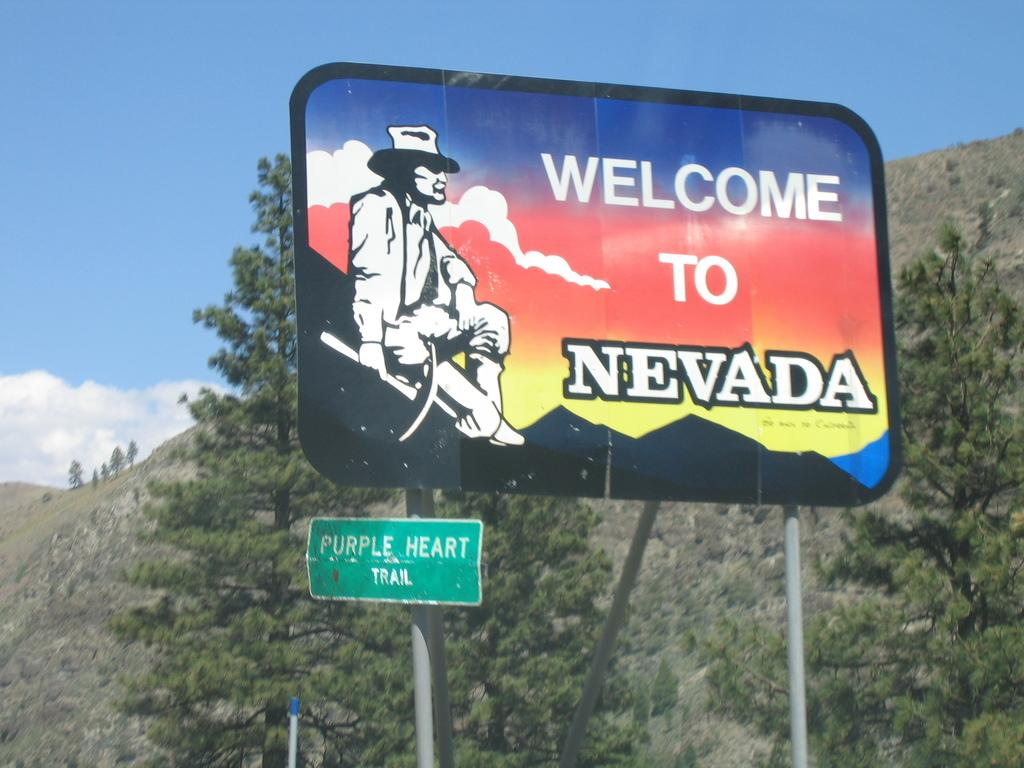<image>
Summarize the visual content of the image. A hilly landscape with a large sign that says Welcome To Nevada 